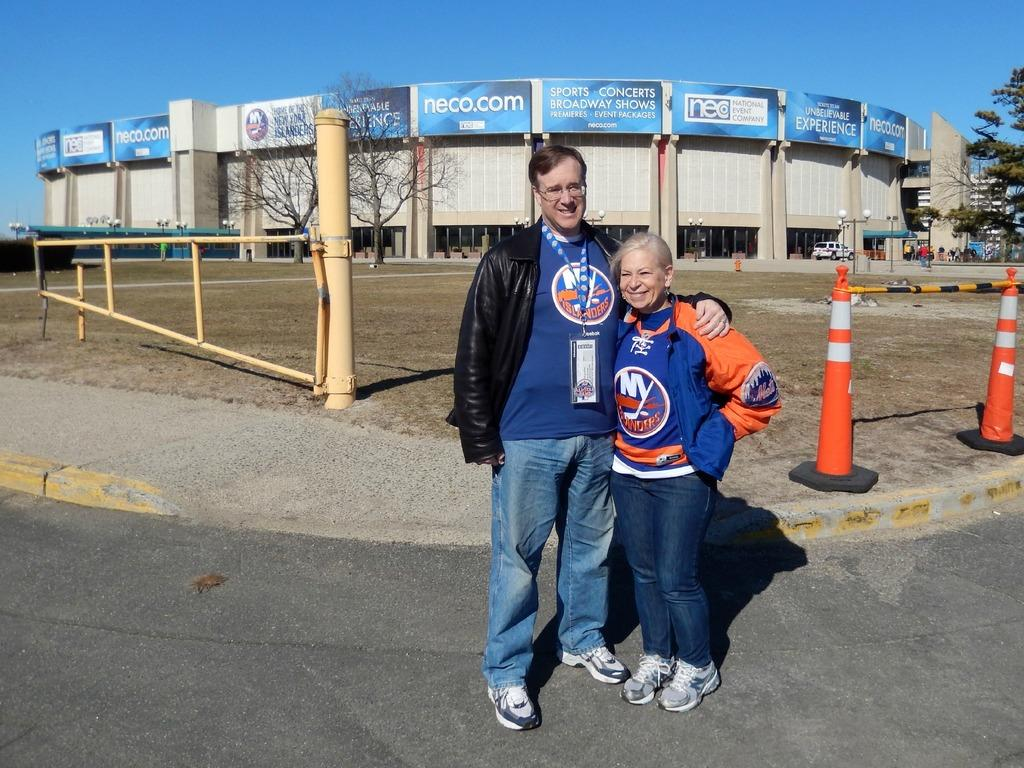<image>
Summarize the visual content of the image. A man and woman are posing for a picture together with NY iSLANDERS SHIRTS and a website neco.com advertised in the background. 